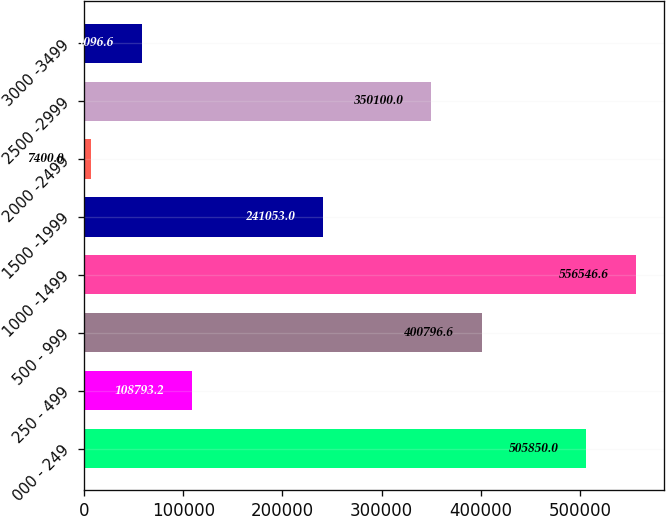Convert chart to OTSL. <chart><loc_0><loc_0><loc_500><loc_500><bar_chart><fcel>000 - 249<fcel>250 - 499<fcel>500 - 999<fcel>1000 -1499<fcel>1500 -1999<fcel>2000 -2499<fcel>2500 -2999<fcel>3000 -3499<nl><fcel>505850<fcel>108793<fcel>400797<fcel>556547<fcel>241053<fcel>7400<fcel>350100<fcel>58096.6<nl></chart> 